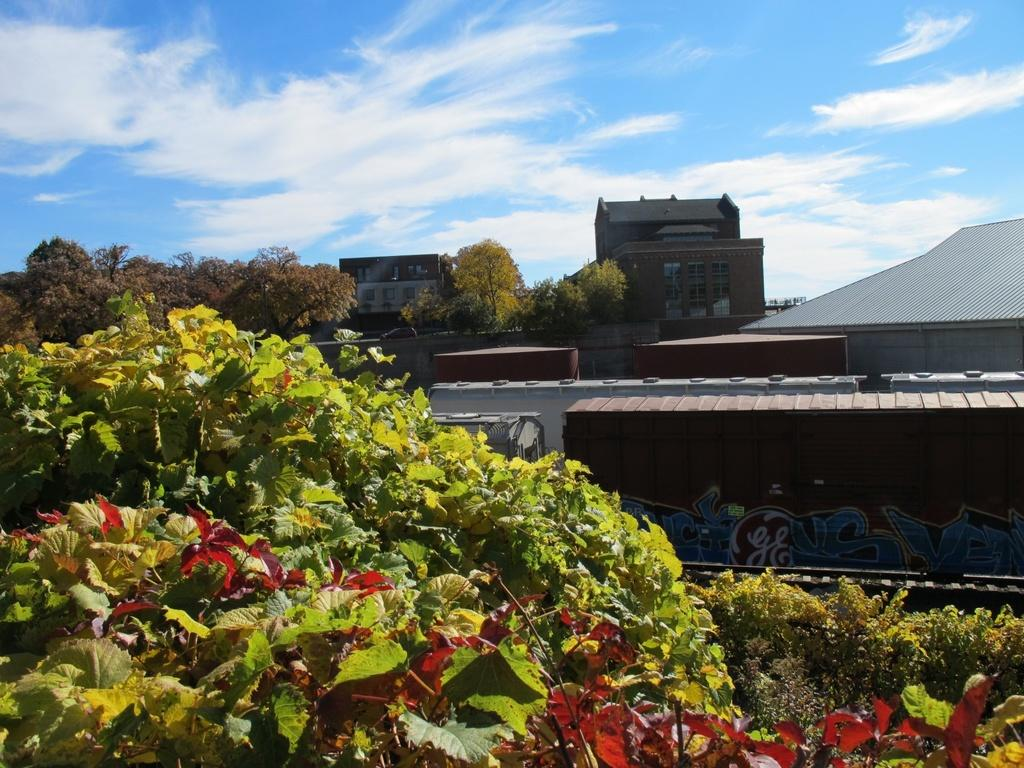What is the main feature in the foreground of the image? There are many leaves in the foreground of the image. What can be seen on the left side of the image? There is a tree on the left side of the image. What is visible in the background of the image? The background of the image is the blue sky. What type of cord is hanging from the tree in the image? There is no cord hanging from the tree in the image; it only features leaves and a tree. 